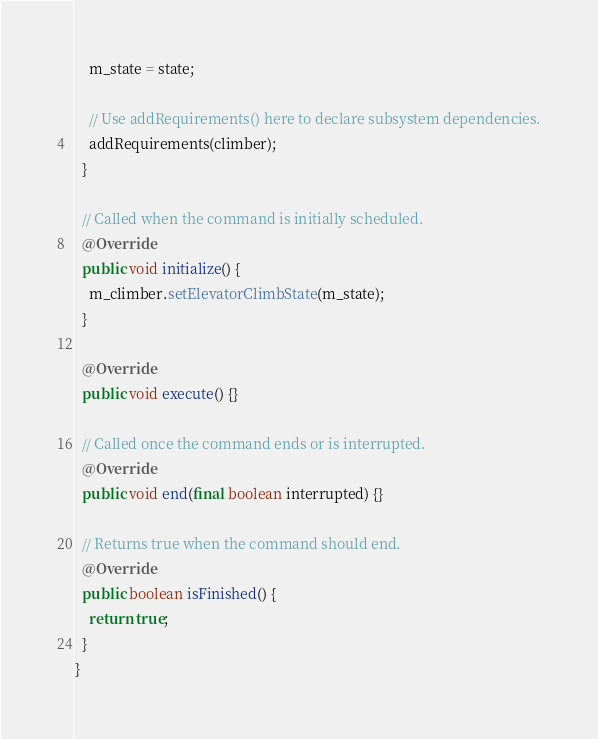<code> <loc_0><loc_0><loc_500><loc_500><_Java_>    m_state = state;

    // Use addRequirements() here to declare subsystem dependencies.
    addRequirements(climber);
  }

  // Called when the command is initially scheduled.
  @Override
  public void initialize() {
    m_climber.setElevatorClimbState(m_state);
  }

  @Override
  public void execute() {}

  // Called once the command ends or is interrupted.
  @Override
  public void end(final boolean interrupted) {}

  // Returns true when the command should end.
  @Override
  public boolean isFinished() {
    return true;
  }
}
</code> 